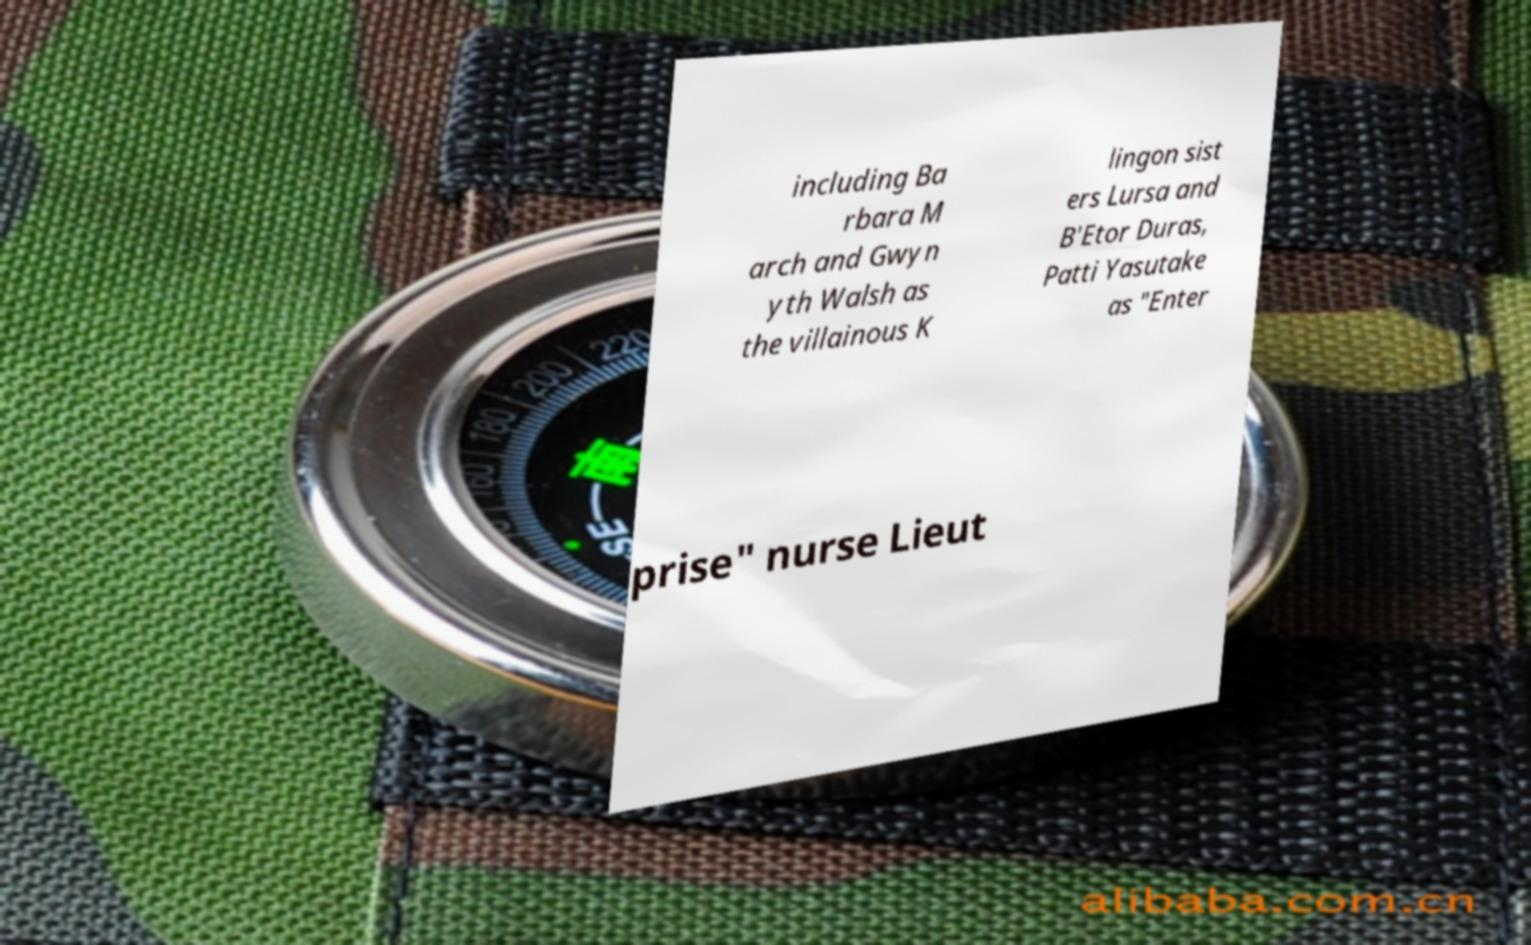Could you extract and type out the text from this image? including Ba rbara M arch and Gwyn yth Walsh as the villainous K lingon sist ers Lursa and B'Etor Duras, Patti Yasutake as "Enter prise" nurse Lieut 